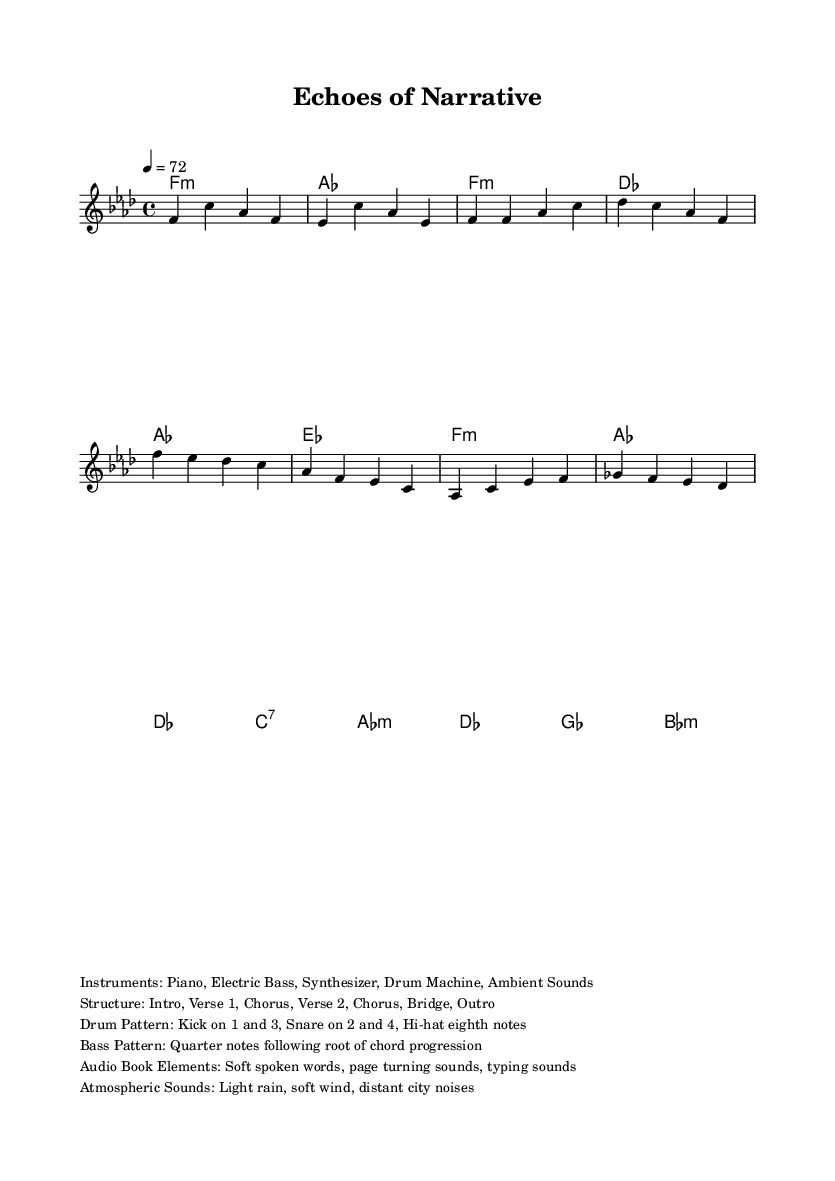What is the key signature of this music? The key signature is located at the beginning of the staff, indicating the key of F minor, which has four flats (B♭, E♭, A♭, D♭).
Answer: F minor What is the time signature of this music? The time signature is placed after the key signature, showing a 4/4 measure. This indicates there are four beats in each measure and a quarter note receives one beat.
Answer: 4/4 What is the tempo marking for this piece? The tempo marking appears above the staff and states "4 = 72," meaning the quarter note (4) is to be played at a speed of 72 beats per minute.
Answer: 72 How many sections are in the structure of the piece? The structure is outlined in the markup and consists of seven distinct sections: Intro, Verse 1, Chorus, Verse 2, Chorus, Bridge, and Outro.
Answer: 7 What instruments are used in this composition? The instruments are listed in the markup section and include Piano, Electric Bass, Synthesizer, Drum Machine, and Ambient Sounds.
Answer: Piano, Electric Bass, Synthesizer, Drum Machine, Ambient Sounds What are the types of sounds included as audiobook elements? The markup mentions specific sounds that contribute to the audiobook elements, which are Soft spoken words, page turning sounds, and typing sounds.
Answer: Soft spoken words, page turning sounds, typing sounds What atmospheric sounds enhance this music piece? The atmospheric sounds are detailed in the markup and include Light rain, soft wind, and distant city noises, contributing to the overall mood and texture of the piece.
Answer: Light rain, soft wind, distant city noises 